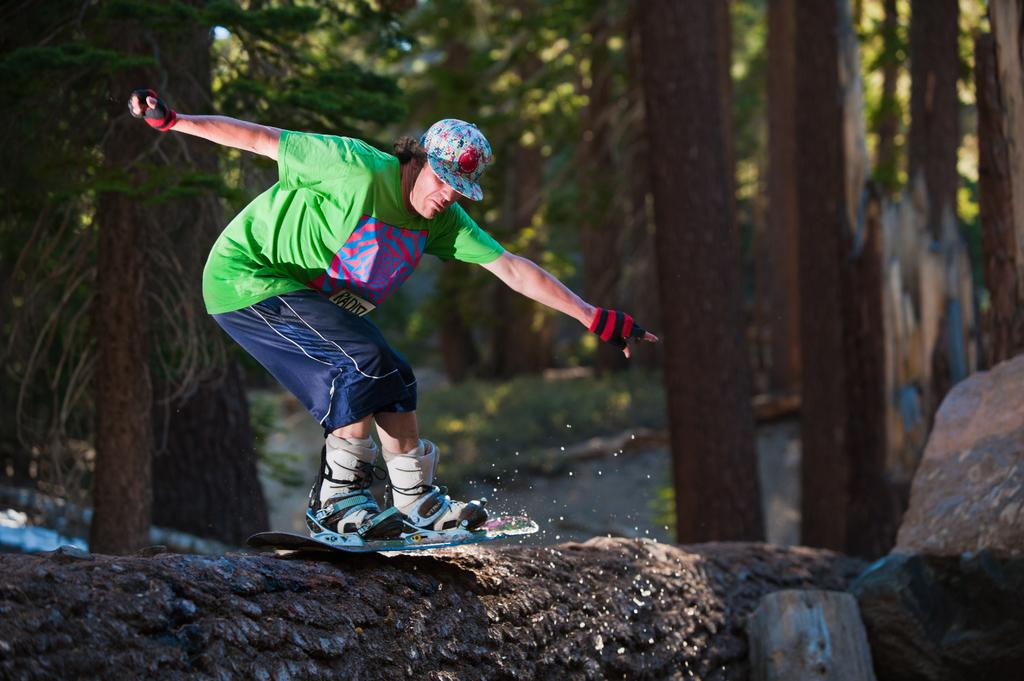What is the person in the image doing? The person is skating with a skateboard. What type of clothing is the person wearing on their head? The person is wearing a cap. What type of clothing is the person wearing on their hands? The person is wearing gloves. What type of clothing is the person wearing on their feet? The person is wearing shoes. Where is the skating taking place? The skating is taking place on a platform. What can be seen in the background of the image? There are trees in the background of the image. What type of dress is the person wearing in the image? There is no dress mentioned in the facts provided. The person is wearing a cap, gloves, and shoes, but no dress is mentioned. 